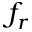Convert formula to latex. <formula><loc_0><loc_0><loc_500><loc_500>f _ { r }</formula> 